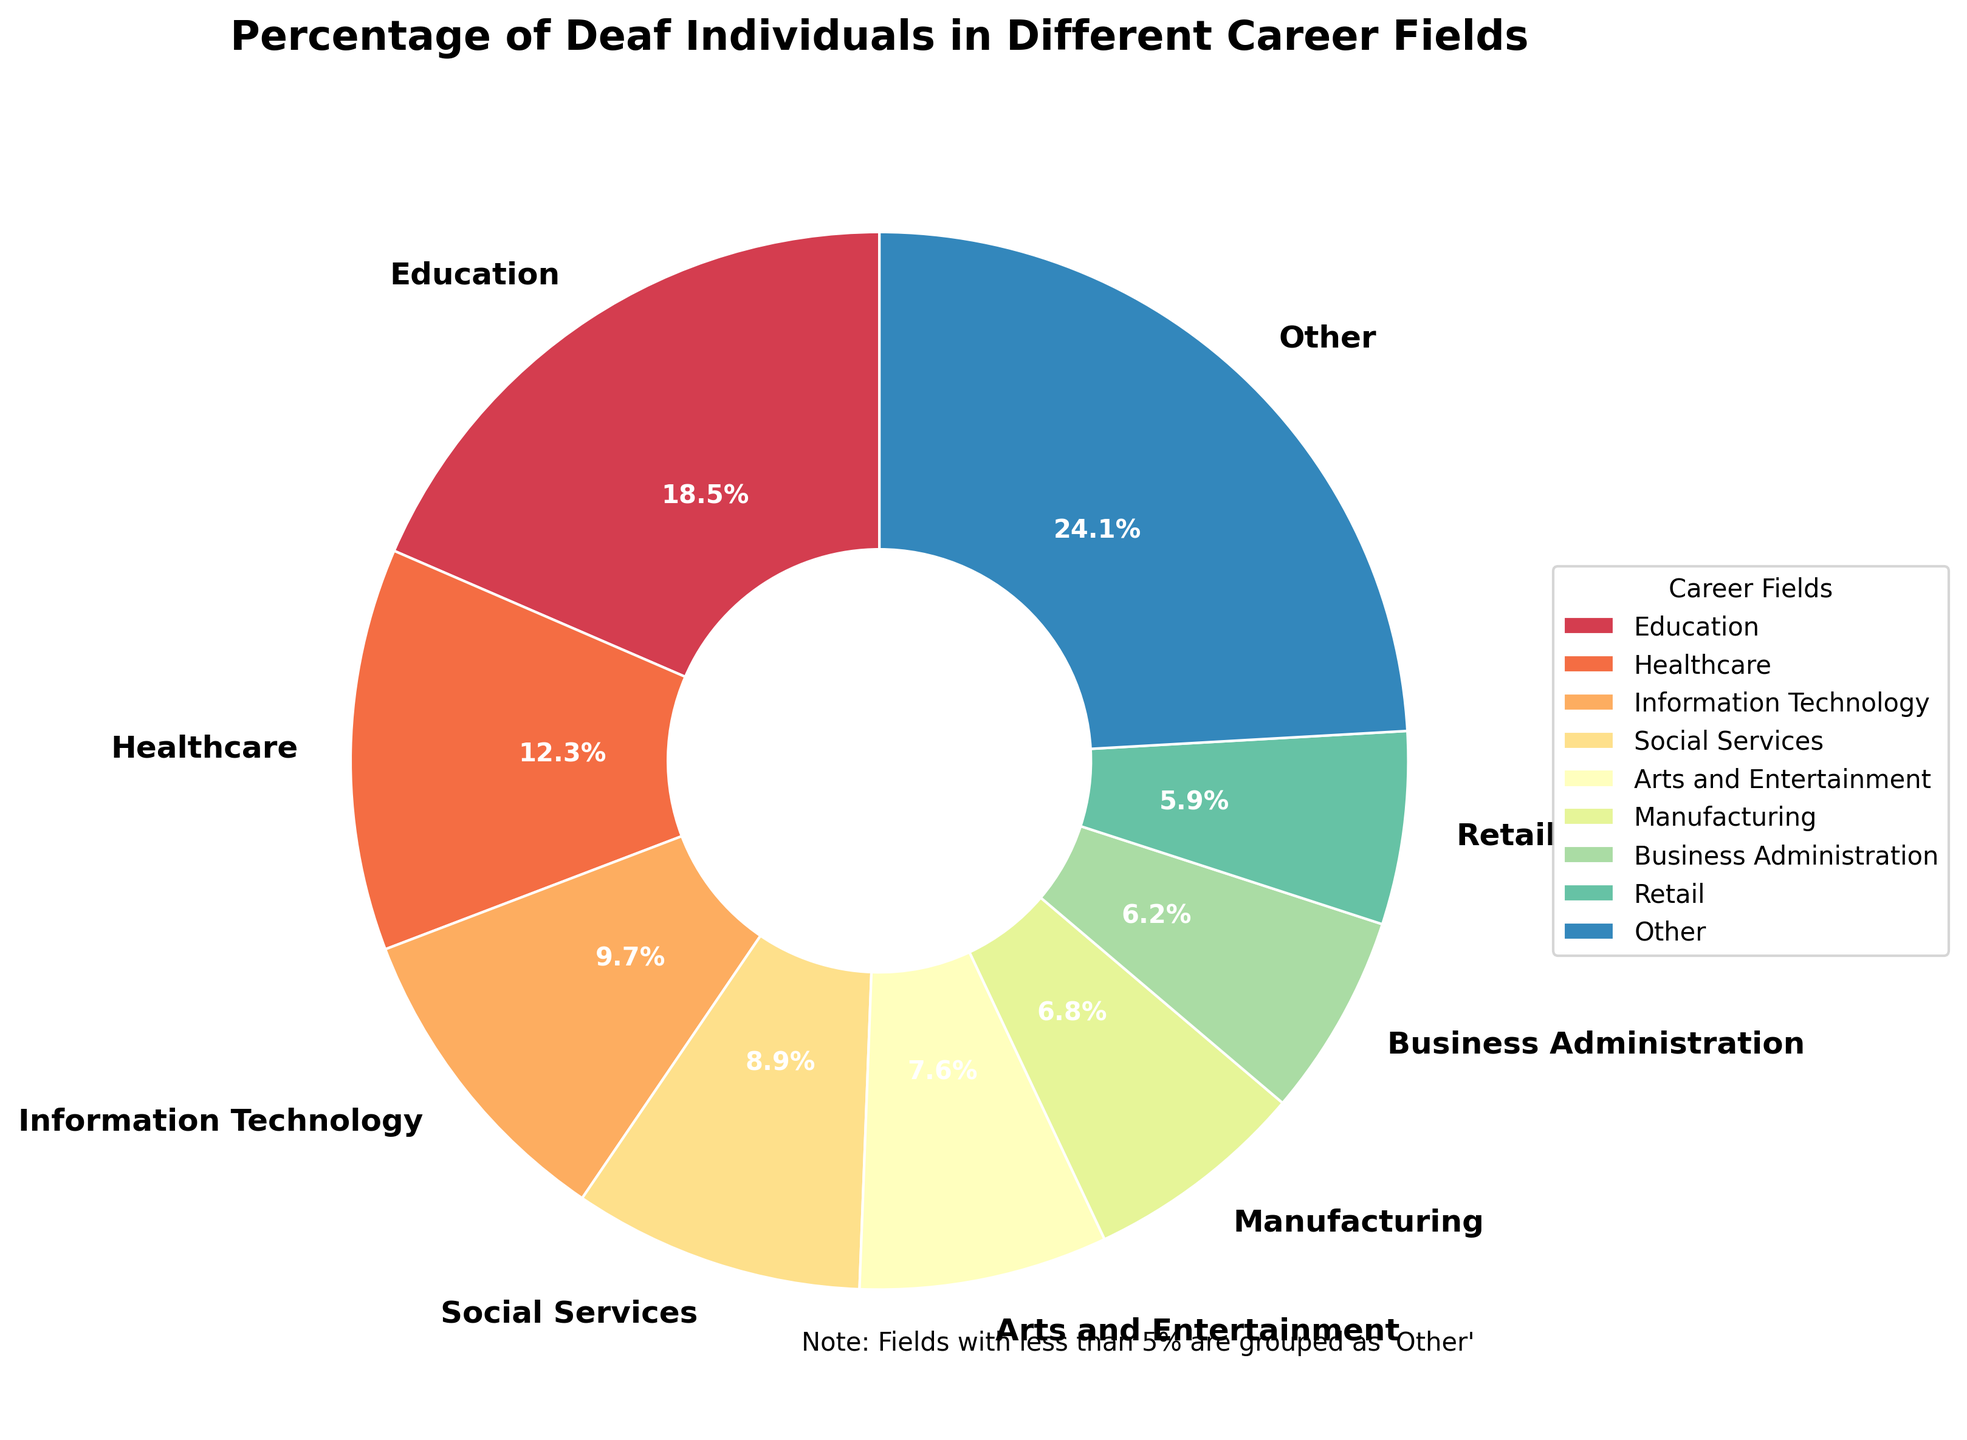Who has the highest percentage among the career fields? The pie chart shows that the Education sector has the largest wedge and the highest percentage of deaf individuals. This can be identified by the biggest portion of the pie chart which is labeled as "Education".
Answer: Education How many career fields are grouped under "Other"? The chart shows the top 8 career fields individually and groups the rest under "Other"; by counting the career fields listed separately (8 fields) and knowing there are 15 fields in total, the remaining 7 are grouped under "Other".
Answer: 7 Which career field has a higher percentage, Healthcare or Information Technology? By comparing the size of the wedges, the pie chart shows that Healthcare has a larger percentage (12.3%) compared to Information Technology (9.7%).
Answer: Healthcare What is the combined percentage of deaf individuals in Business Administration and Retail? According to the pie chart, Business Administration accounts for 6.2% and Retail for 5.9%. Adding these percentages together gives 6.2% + 5.9% = 12.1%.
Answer: 12.1% If you combine Social Services and Arts and Entertainment, does their total percentage exceed Information Technology? Social Services has 8.9% and Arts and Entertainment has 7.6%. Summing these gives 8.9% + 7.6% = 16.5%, which is greater than Information Technology's 9.7%.
Answer: Yes Which career fields are under the "Other" category? The "Other" category includes the fields with less than 5% representation: Science and Research (5.4%), Legal Services (4.8%), Hospitality (4.3%), Construction (3.7%), Agriculture (2.5%), Transportation (2.1%), and Government (1.3%).
Answer: Science and Research, Legal Services, Hospitality, Construction, Agriculture, Transportation, Government Is the percentage of deaf individuals in Manufacturing greater than half of those in Education? The percentage for Manufacturing is 6.8% and for Education is 18.5%. Half of Education's percentage is 18.5% / 2 = 9.25%, which is greater than 6.8%.
Answer: No What is the average percentage of the top three career fields? The top three fields are Education (18.5%), Healthcare (12.3%), and Information Technology (9.7%). The average is (18.5% + 12.3% + 9.7%)/3 = 40.5%/3 = 13.5%.
Answer: 13.5% How does the percentage in Construction compare to Agriculture? The pie chart shows that Construction has 3.7%, which is greater than Agriculture's 2.5%.
Answer: Construction is greater 